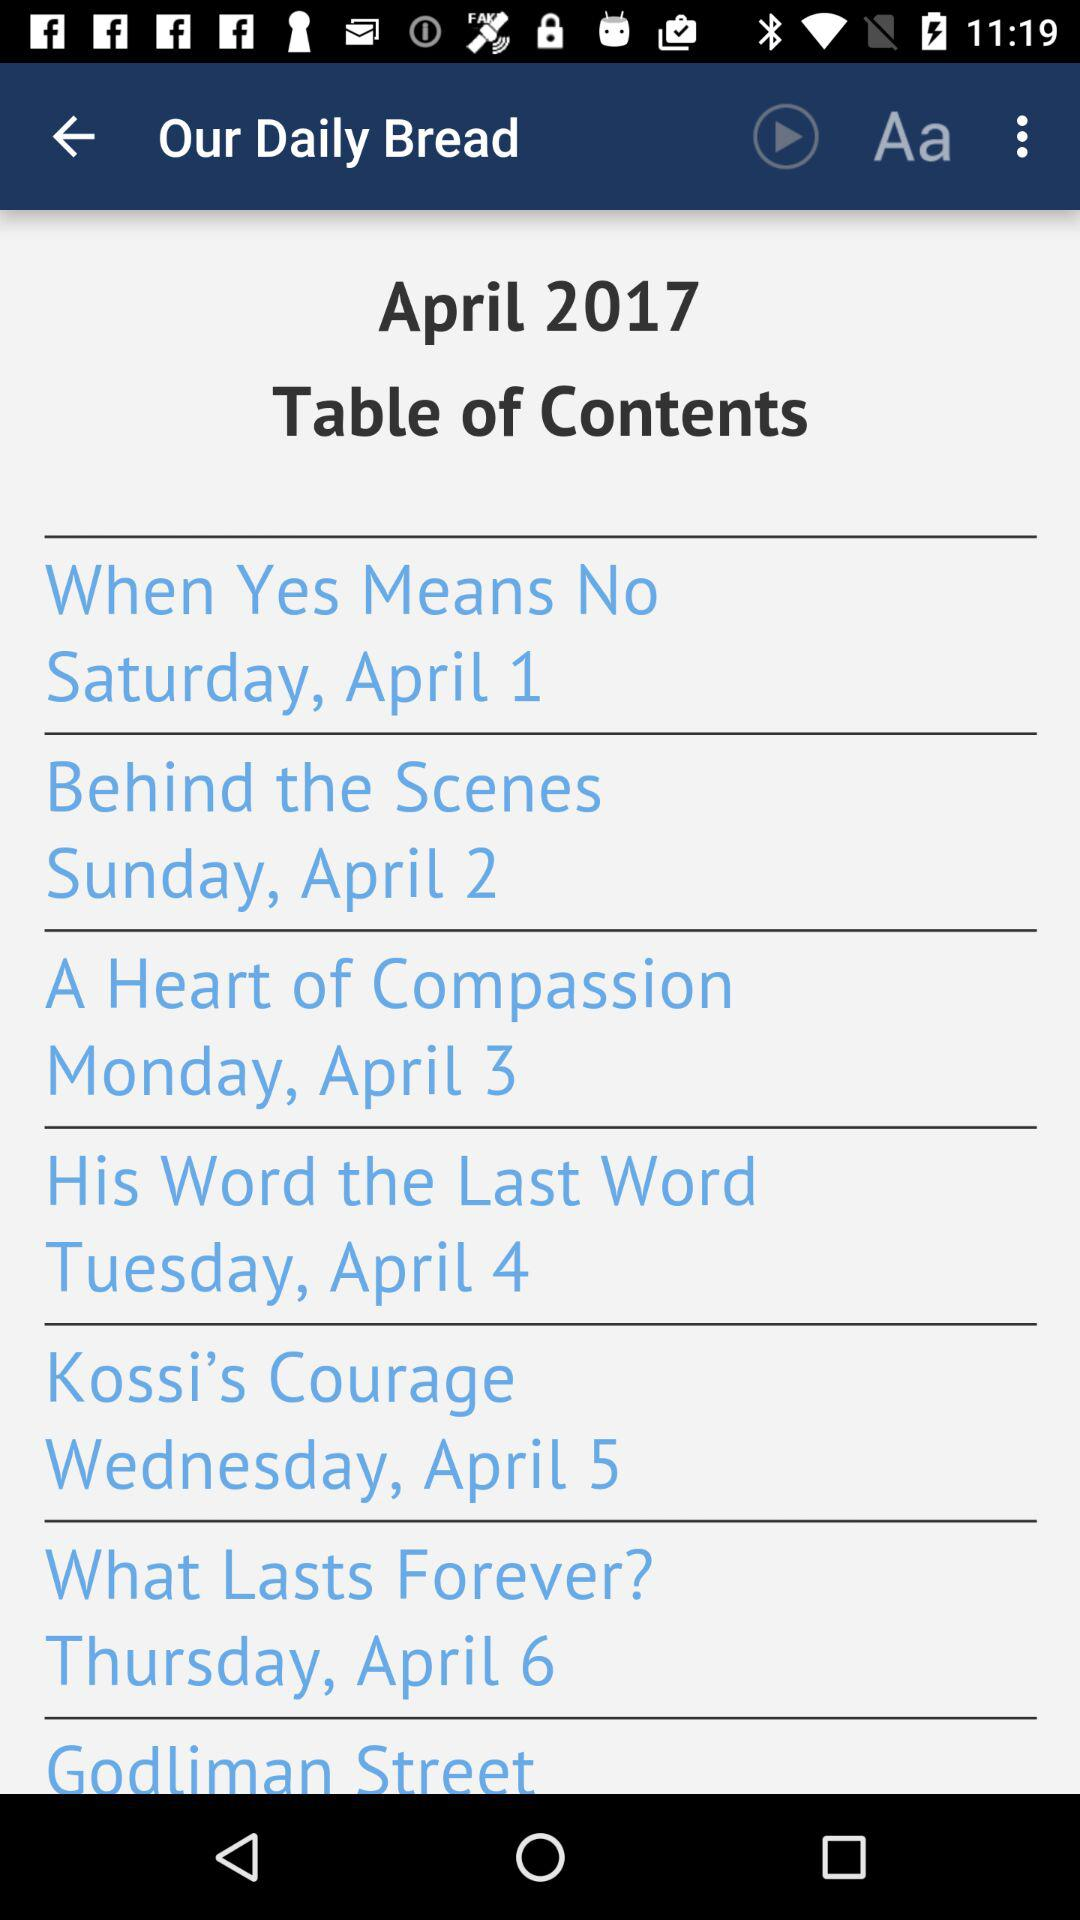What month and year's table of contents is shown? It is shown for the month of April and the year 2017. 